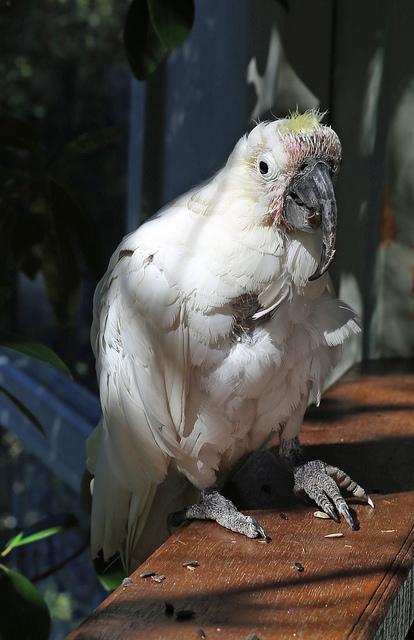What color is this bird's beak?
Answer briefly. Black. Is the bird standing on both feet?
Be succinct. Yes. How many feathers does the bird have?
Answer briefly. 100. How many toes does the bird have?
Answer briefly. 4. Is this a live animal?
Concise answer only. Yes. 